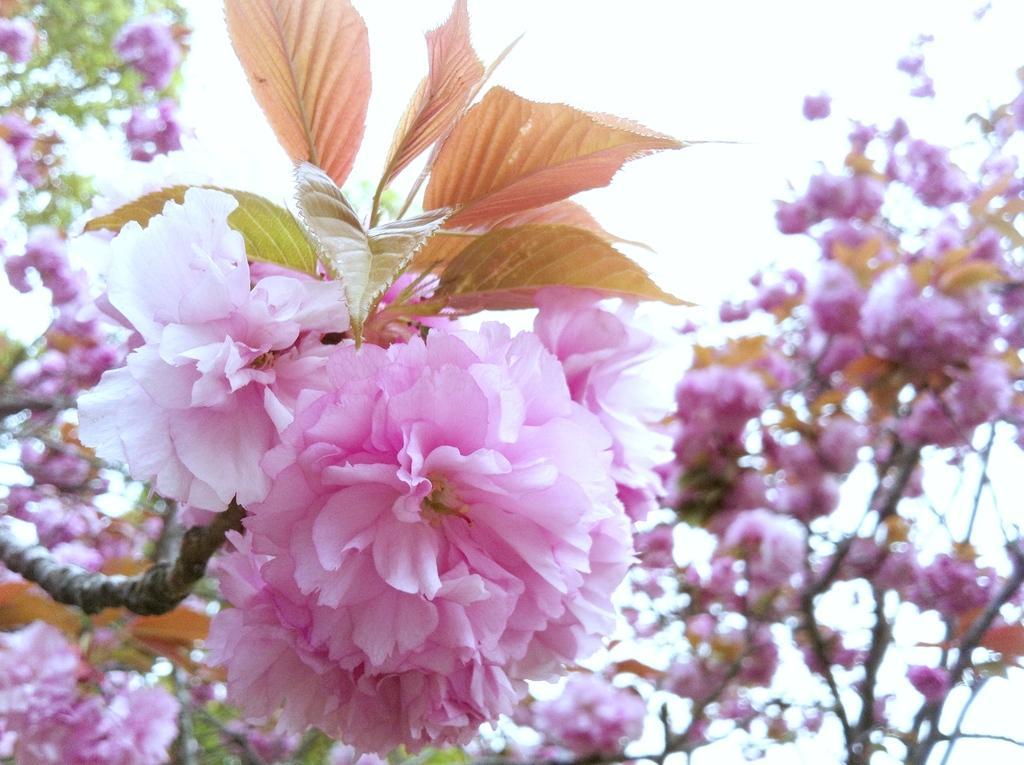Can you describe this image briefly? In this image, we can see cherry blossom trees. 